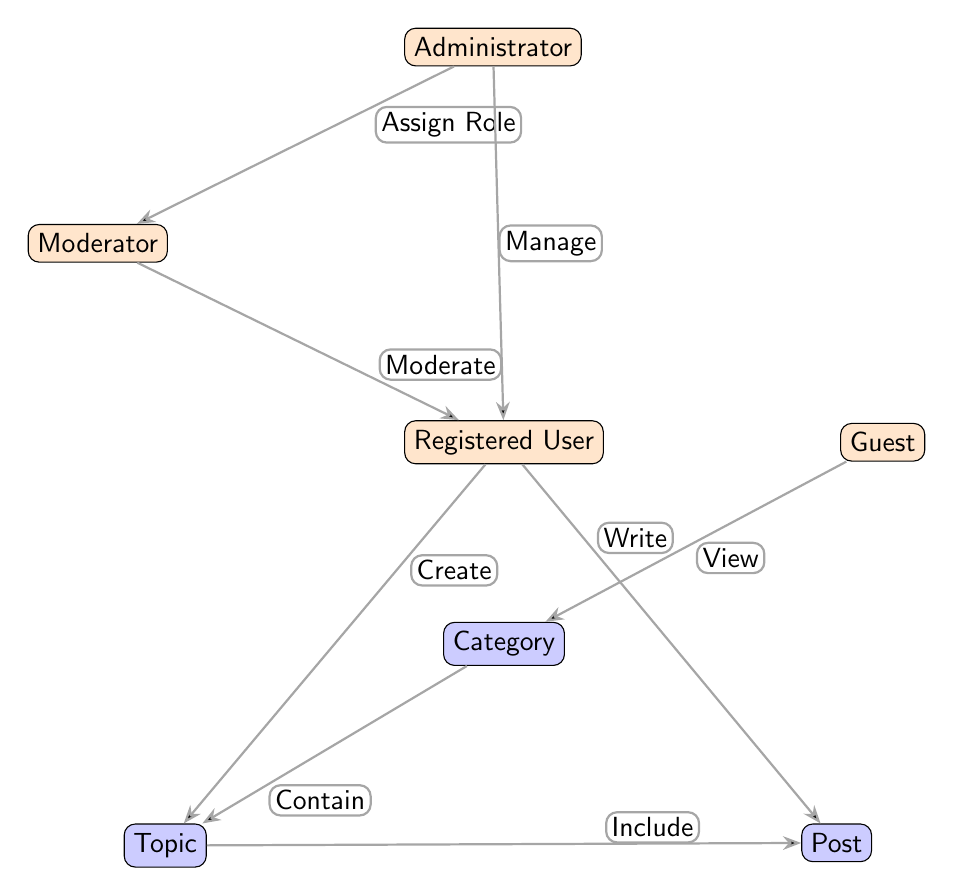What are the roles depicted in the diagram? The diagram includes three main user roles: Administrator, Moderator, and Registered User. These roles are represented by distinct nodes.
Answer: Administrator, Moderator, Registered User How many edges are there in the diagram? By counting the lines connecting the nodes, we find a total of six edges in the diagram. Each edge represents a relationship between user roles and content.
Answer: 6 What role can a user assign to a Moderator? The Administrator has the ability to "Assign Role" to the Moderator, as indicated by the directed edge pointing from Administrator to Moderator.
Answer: Assign Role Which user role can create topics? The Registered User is allowed to "Create" topics in the forum, as shown by the directed edge from Registered User to Topic indicating this permission.
Answer: Registered User What permission does a Guest have regarding the Category? The Guest has the permission to "View" the Category, indicated by the edge connecting Guest to Category with this label specified.
Answer: View How does a Topic relate to Posts? The Topic "Includes" Posts, as shown by the directed edge from Topic to Post, this indicates that every topic contains one or more posts.
Answer: Include Who can moderate Registered Users? The Moderator has the ability to "Moderate" Registered Users according to the edge labeled with this permission from Moderator to Registered User.
Answer: Moderator What actions can a Registered User perform on posts? A Registered User can "Write" posts, according to the directed edge labeled "Write" that connects Registered User to Post in the diagram.
Answer: Write What is the hierarchical structure represented in the diagram? The diagram indicates a hierarchical structure where the Administrator oversees both the Moderator and Registered User roles, displaying a clear chain of command.
Answer: Administrator > Moderator > Registered User 